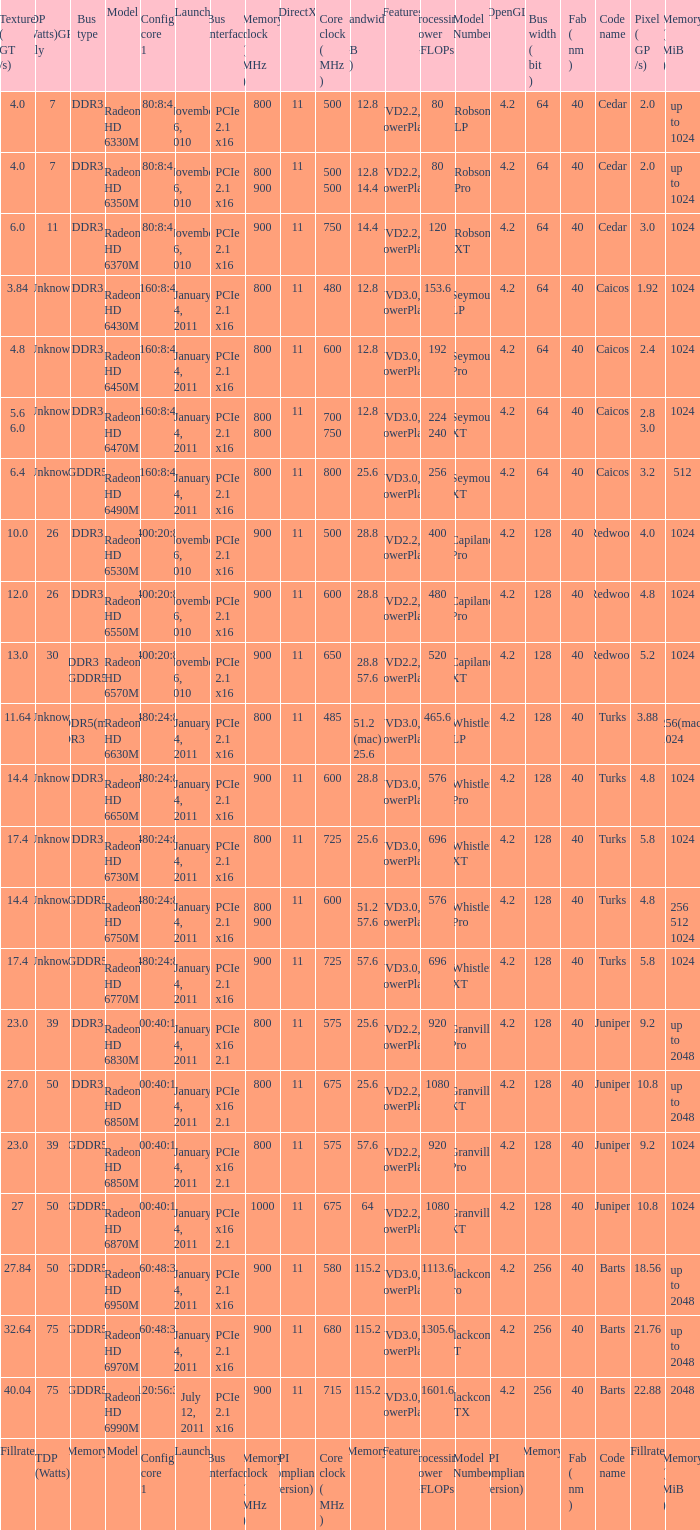How many values for fab(nm) if the model number is Whistler LP? 1.0. 